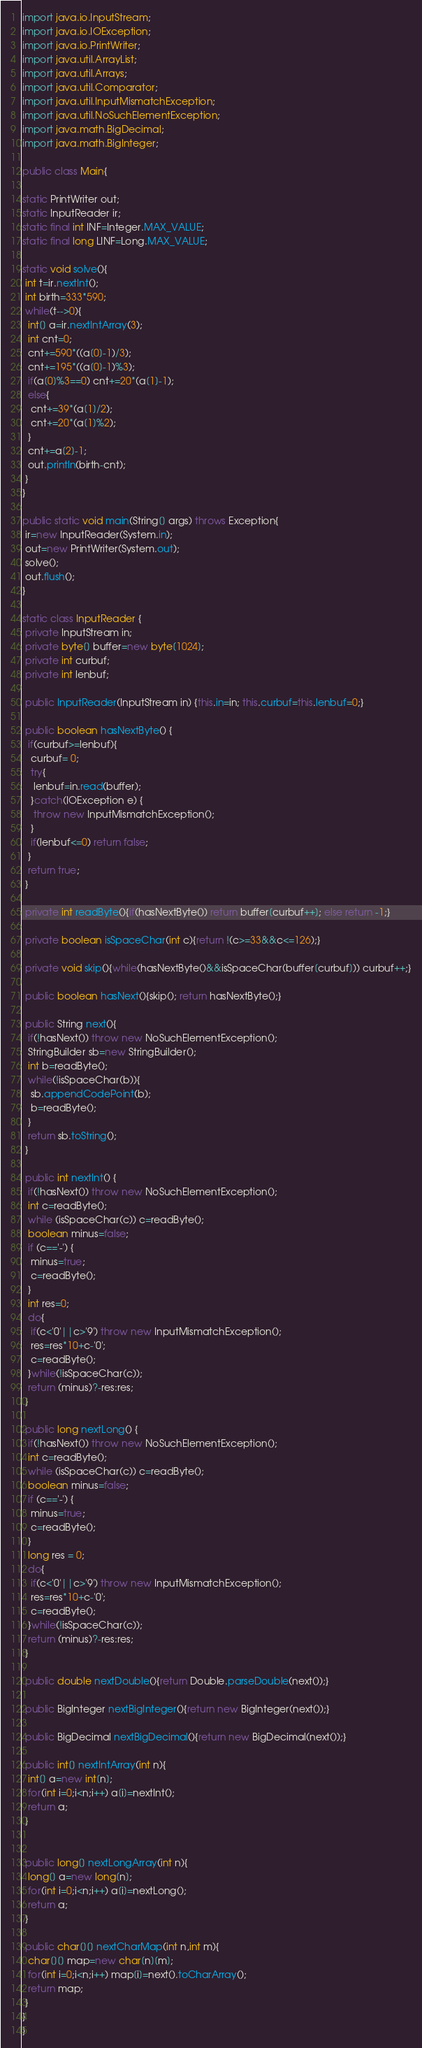Convert code to text. <code><loc_0><loc_0><loc_500><loc_500><_Java_>import java.io.InputStream;
import java.io.IOException;
import java.io.PrintWriter;
import java.util.ArrayList;
import java.util.Arrays;
import java.util.Comparator;
import java.util.InputMismatchException;
import java.util.NoSuchElementException;
import java.math.BigDecimal;
import java.math.BigInteger;
    
public class Main{
 
static PrintWriter out;
static InputReader ir;
static final int INF=Integer.MAX_VALUE;
static final long LINF=Long.MAX_VALUE;
 
static void solve(){
 int t=ir.nextInt();
 int birth=333*590;
 while(t-->0){
  int[] a=ir.nextIntArray(3);
  int cnt=0;
  cnt+=590*((a[0]-1)/3);
  cnt+=195*((a[0]-1)%3);
  if(a[0]%3==0) cnt+=20*(a[1]-1);
  else{
   cnt+=39*(a[1]/2);
   cnt+=20*(a[1]%2);
  }
  cnt+=a[2]-1;
  out.println(birth-cnt);
 }
}

public static void main(String[] args) throws Exception{
 ir=new InputReader(System.in);
 out=new PrintWriter(System.out);
 solve();
 out.flush();
}

static class InputReader {
 private InputStream in;
 private byte[] buffer=new byte[1024];
 private int curbuf;
 private int lenbuf;

 public InputReader(InputStream in) {this.in=in; this.curbuf=this.lenbuf=0;}
 
 public boolean hasNextByte() {
  if(curbuf>=lenbuf){
   curbuf= 0;
   try{
    lenbuf=in.read(buffer);
   }catch(IOException e) {
    throw new InputMismatchException();
   }
   if(lenbuf<=0) return false;
  }
  return true;
 }

 private int readByte(){if(hasNextByte()) return buffer[curbuf++]; else return -1;}
 
 private boolean isSpaceChar(int c){return !(c>=33&&c<=126);}
 
 private void skip(){while(hasNextByte()&&isSpaceChar(buffer[curbuf])) curbuf++;}
 
 public boolean hasNext(){skip(); return hasNextByte();}
 
 public String next(){
  if(!hasNext()) throw new NoSuchElementException();
  StringBuilder sb=new StringBuilder();
  int b=readByte();
  while(!isSpaceChar(b)){
   sb.appendCodePoint(b);
   b=readByte();
  }
  return sb.toString();
 }
 
 public int nextInt() {
  if(!hasNext()) throw new NoSuchElementException();
  int c=readByte();
  while (isSpaceChar(c)) c=readByte();
  boolean minus=false;
  if (c=='-') {
   minus=true;
   c=readByte();
  }
  int res=0;
  do{
   if(c<'0'||c>'9') throw new InputMismatchException();
   res=res*10+c-'0';
   c=readByte();
  }while(!isSpaceChar(c));
  return (minus)?-res:res;
 }
 
 public long nextLong() {
  if(!hasNext()) throw new NoSuchElementException();
  int c=readByte();
  while (isSpaceChar(c)) c=readByte();
  boolean minus=false;
  if (c=='-') {
   minus=true;
   c=readByte();
  }
  long res = 0;
  do{
   if(c<'0'||c>'9') throw new InputMismatchException();
   res=res*10+c-'0';
   c=readByte();
  }while(!isSpaceChar(c));
  return (minus)?-res:res;
 }
 
 public double nextDouble(){return Double.parseDouble(next());}
 
 public BigInteger nextBigInteger(){return new BigInteger(next());}
 
 public BigDecimal nextBigDecimal(){return new BigDecimal(next());}
 
 public int[] nextIntArray(int n){
  int[] a=new int[n];
  for(int i=0;i<n;i++) a[i]=nextInt();
  return a;
 }
 
 
 public long[] nextLongArray(int n){
  long[] a=new long[n];
  for(int i=0;i<n;i++) a[i]=nextLong();
  return a;
 }

 public char[][] nextCharMap(int n,int m){
  char[][] map=new char[n][m];
  for(int i=0;i<n;i++) map[i]=next().toCharArray();
  return map;
 }
}
}</code> 